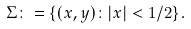<formula> <loc_0><loc_0><loc_500><loc_500>\Sigma \colon = \{ ( x , y ) \colon | x | < 1 / 2 \} .</formula> 